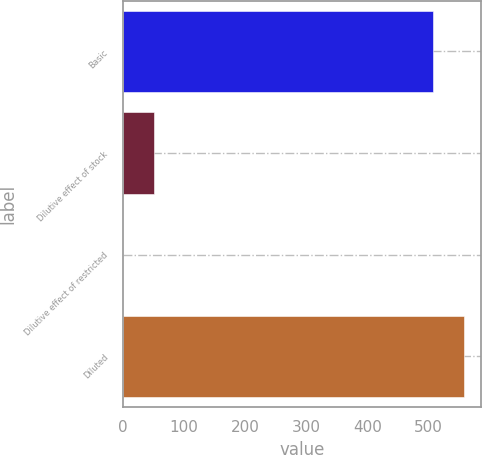<chart> <loc_0><loc_0><loc_500><loc_500><bar_chart><fcel>Basic<fcel>Dilutive effect of stock<fcel>Dilutive effect of restricted<fcel>Diluted<nl><fcel>507<fcel>51.22<fcel>0.4<fcel>557.82<nl></chart> 